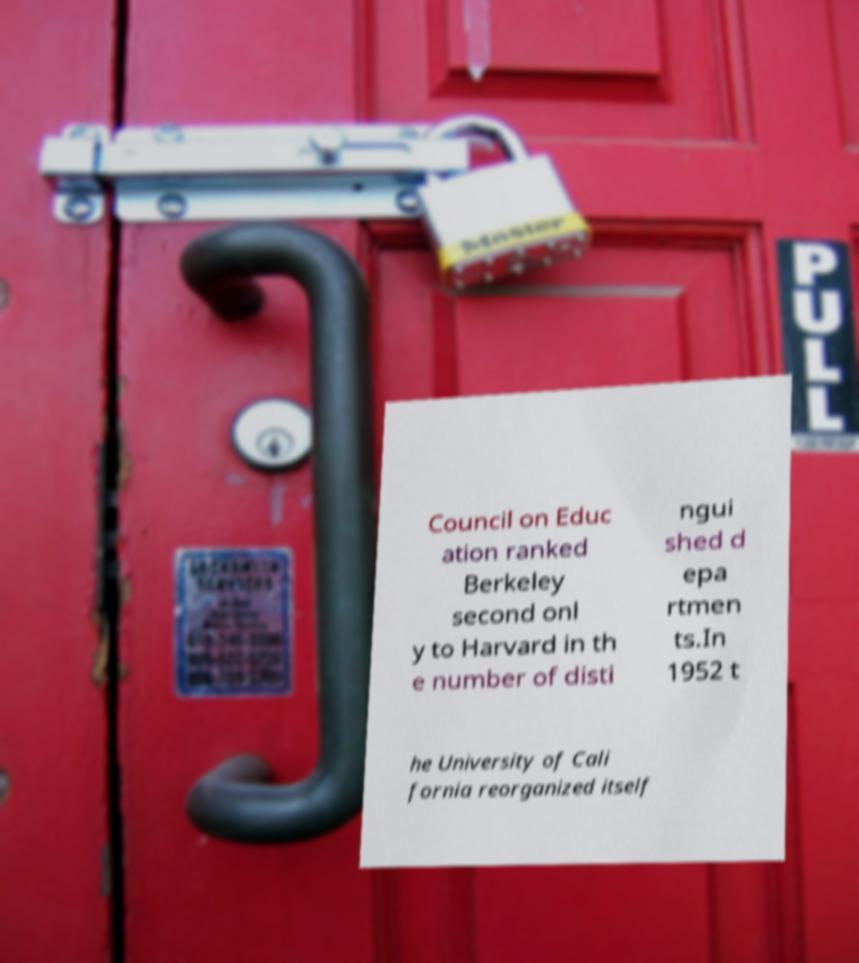Please read and relay the text visible in this image. What does it say? Council on Educ ation ranked Berkeley second onl y to Harvard in th e number of disti ngui shed d epa rtmen ts.In 1952 t he University of Cali fornia reorganized itself 